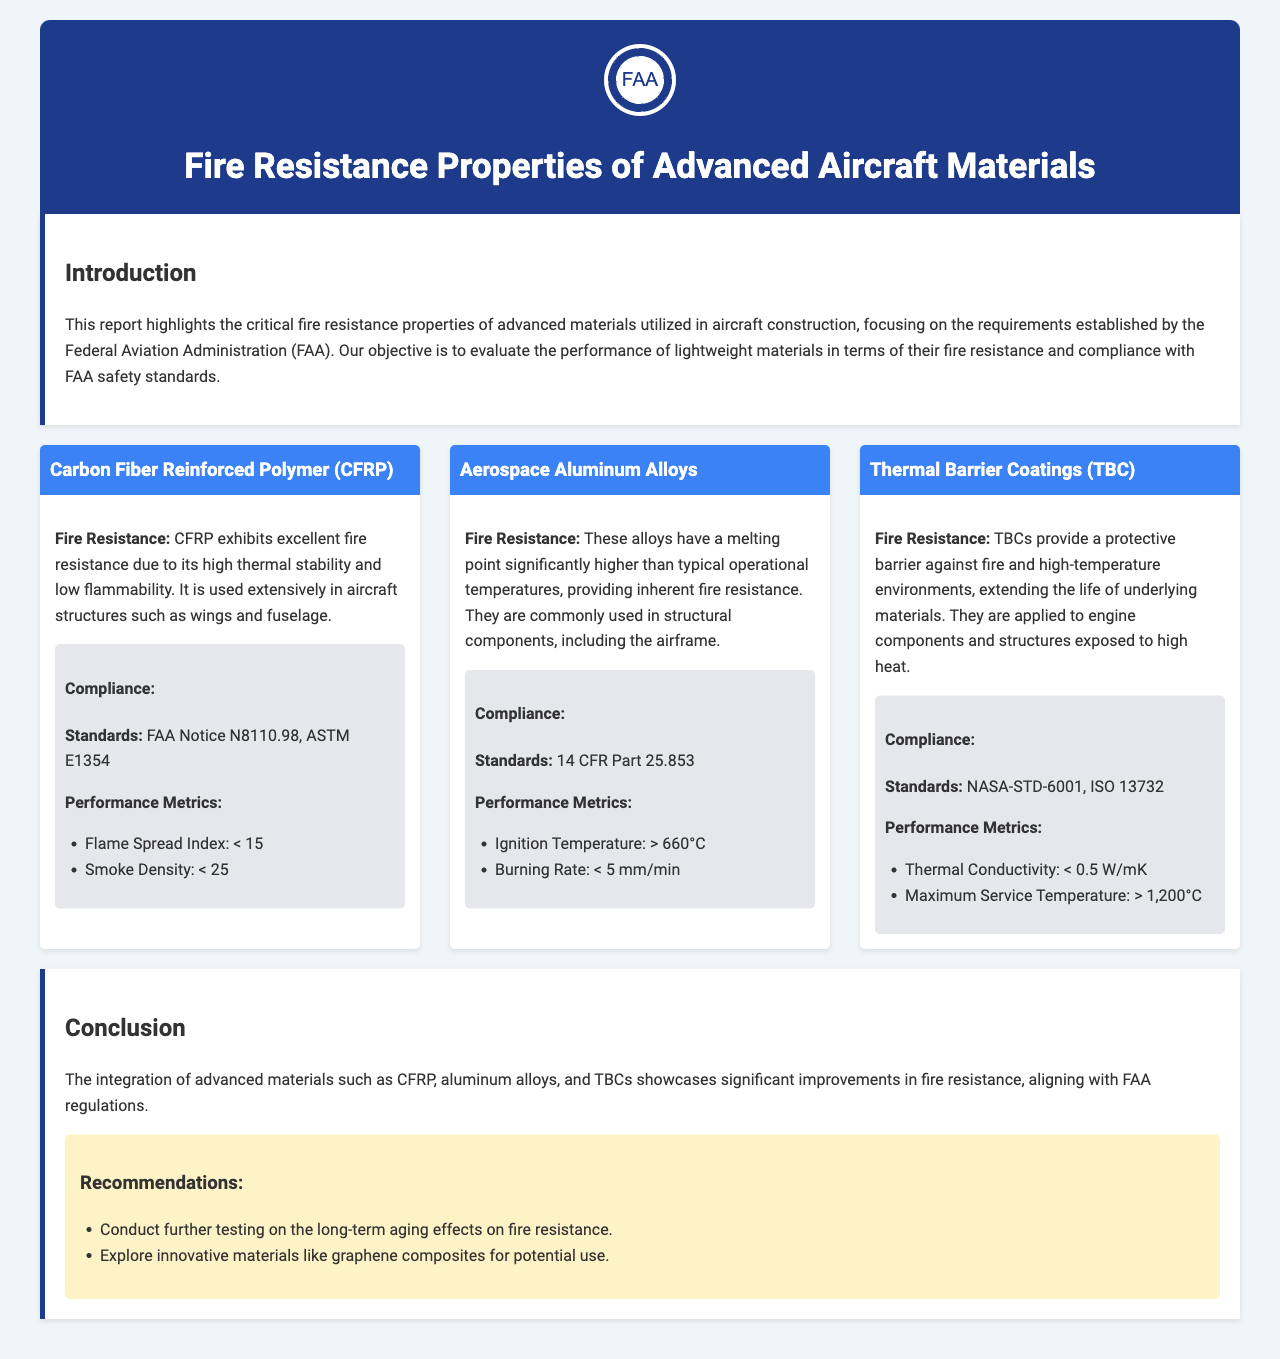What is the title of the report? The title of the report is stated in the header section, which is "Fire Resistance Properties of Advanced Aircraft Materials."
Answer: Fire Resistance Properties of Advanced Aircraft Materials What material is used extensively in aircraft structures such as wings and fuselage? The document specifies that Carbon Fiber Reinforced Polymer (CFRP) is used extensively in these areas.
Answer: Carbon Fiber Reinforced Polymer (CFRP) What is the Flame Spread Index for CFRP? The report lists the performance metrics for CFRP, including the Flame Spread Index as less than 15.
Answer: < 15 What is the maximum service temperature for Thermal Barrier Coatings? The performance metrics for Thermal Barrier Coatings state that the Maximum Service Temperature is greater than 1,200 degrees Celsius.
Answer: > 1,200°C What recommendation is made regarding testing? The report recommends conducting further testing on the long-term aging effects on fire resistance.
Answer: Conduct further testing on the long-term aging effects on fire resistance Which standard applies to Aerospace Aluminum Alloys? The compliance section for Aerospace Aluminum Alloys mentions the standard as 14 CFR Part 25.853.
Answer: 14 CFR Part 25.853 What is one of the inherent properties of Aerospace Aluminum Alloys? The document states that these alloys have a high melting point compared to operational temperatures, providing inherent fire resistance.
Answer: High melting point What are two innovative materials suggested for exploration? The recommendations section suggests exploring innovative materials like graphene composites.
Answer: Graphene composites 